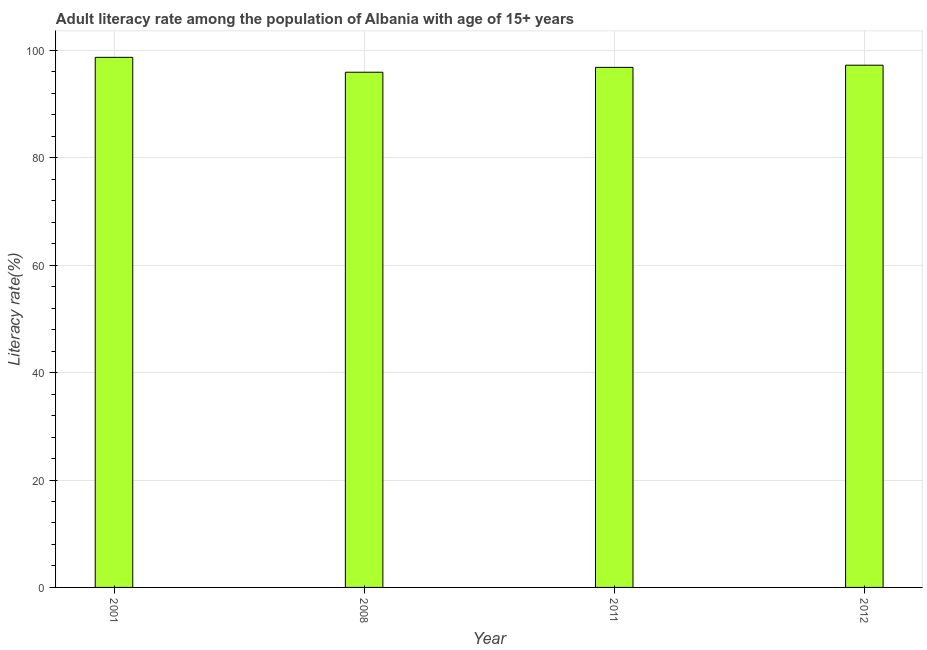Does the graph contain any zero values?
Give a very brief answer. No. What is the title of the graph?
Your response must be concise. Adult literacy rate among the population of Albania with age of 15+ years. What is the label or title of the X-axis?
Your response must be concise. Year. What is the label or title of the Y-axis?
Provide a succinct answer. Literacy rate(%). What is the adult literacy rate in 2001?
Offer a terse response. 98.71. Across all years, what is the maximum adult literacy rate?
Ensure brevity in your answer.  98.71. Across all years, what is the minimum adult literacy rate?
Your answer should be very brief. 95.94. What is the sum of the adult literacy rate?
Your answer should be compact. 388.74. What is the difference between the adult literacy rate in 2001 and 2008?
Provide a succinct answer. 2.77. What is the average adult literacy rate per year?
Your answer should be very brief. 97.19. What is the median adult literacy rate?
Offer a very short reply. 97.05. In how many years, is the adult literacy rate greater than 8 %?
Ensure brevity in your answer.  4. Do a majority of the years between 2008 and 2011 (inclusive) have adult literacy rate greater than 76 %?
Ensure brevity in your answer.  Yes. What is the ratio of the adult literacy rate in 2008 to that in 2012?
Give a very brief answer. 0.99. Is the adult literacy rate in 2011 less than that in 2012?
Your response must be concise. Yes. Is the difference between the adult literacy rate in 2001 and 2011 greater than the difference between any two years?
Keep it short and to the point. No. What is the difference between the highest and the second highest adult literacy rate?
Provide a succinct answer. 1.47. What is the difference between the highest and the lowest adult literacy rate?
Provide a succinct answer. 2.77. How many years are there in the graph?
Offer a very short reply. 4. What is the difference between two consecutive major ticks on the Y-axis?
Make the answer very short. 20. What is the Literacy rate(%) in 2001?
Your answer should be compact. 98.71. What is the Literacy rate(%) in 2008?
Offer a very short reply. 95.94. What is the Literacy rate(%) in 2011?
Make the answer very short. 96.85. What is the Literacy rate(%) of 2012?
Give a very brief answer. 97.25. What is the difference between the Literacy rate(%) in 2001 and 2008?
Keep it short and to the point. 2.77. What is the difference between the Literacy rate(%) in 2001 and 2011?
Provide a short and direct response. 1.87. What is the difference between the Literacy rate(%) in 2001 and 2012?
Offer a terse response. 1.47. What is the difference between the Literacy rate(%) in 2008 and 2011?
Keep it short and to the point. -0.91. What is the difference between the Literacy rate(%) in 2008 and 2012?
Provide a short and direct response. -1.31. What is the difference between the Literacy rate(%) in 2011 and 2012?
Ensure brevity in your answer.  -0.4. What is the ratio of the Literacy rate(%) in 2001 to that in 2011?
Your answer should be compact. 1.02. What is the ratio of the Literacy rate(%) in 2011 to that in 2012?
Your answer should be compact. 1. 